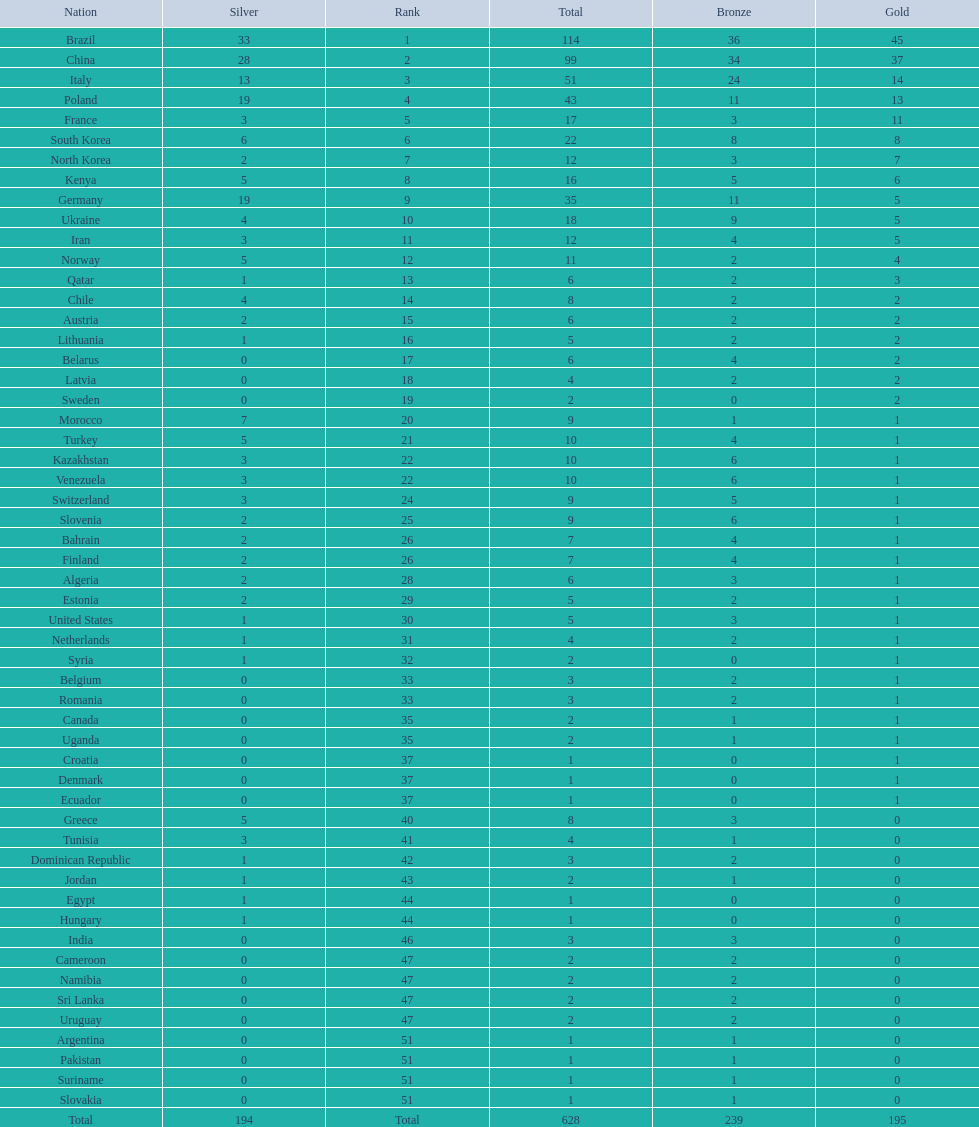South korea has how many more medals that north korea? 10. 